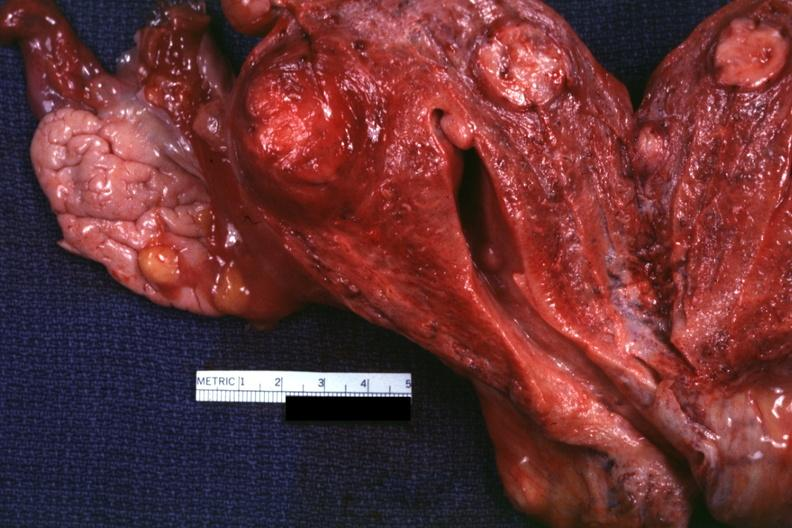s female reproductive present?
Answer the question using a single word or phrase. Yes 